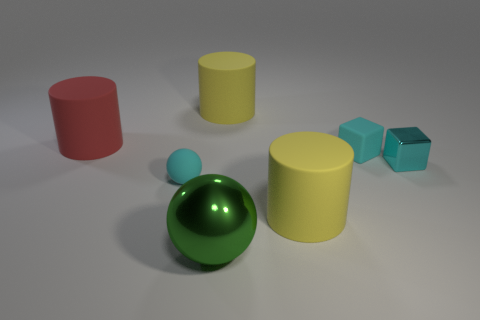How many other things are the same shape as the big green shiny object? 1 